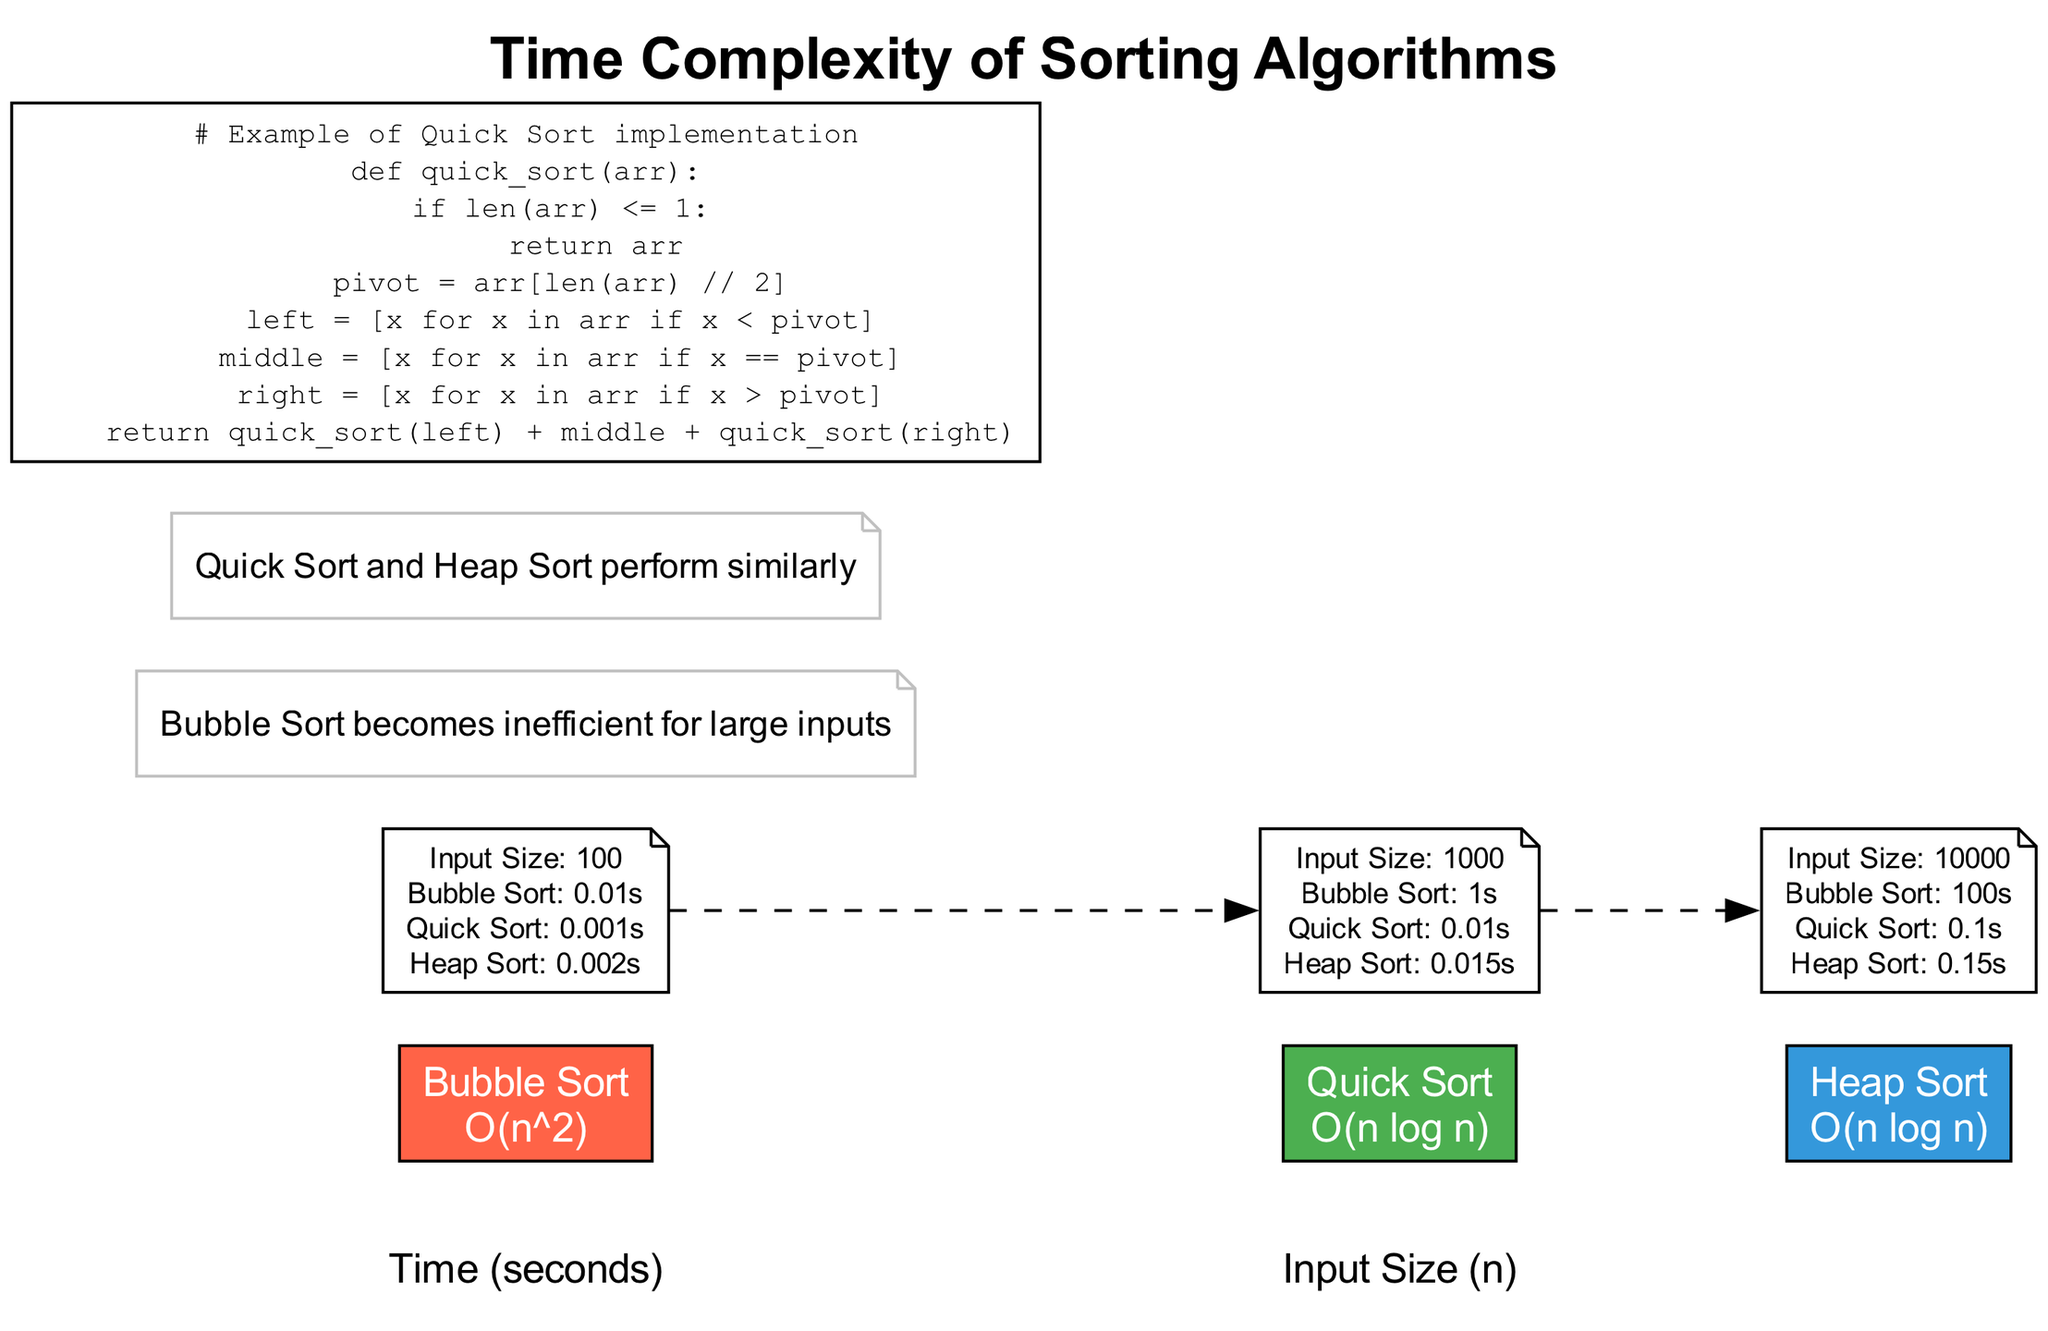What is the time complexity of Quick Sort? The diagram lists the complexity of Quick Sort under its name as "O(n log n)". This is standard information indicated directly within the visual representation of the algorithm.
Answer: O(n log n) What appears to be less efficient for large inputs? The annotation in the diagram explicitly points out that "Bubble Sort becomes inefficient for large inputs", indicating its performance issues as the input size increases.
Answer: Bubble Sort How long does Heap Sort take for an input size of 10,000? For an input size of 10,000, the diagram shows that Heap Sort takes 0.15 seconds. This value is directly taken from the data points marked for Heap Sort at that specific input size.
Answer: 0.15 seconds Which two sorting algorithms perform similarly? The annotation states that "Quick Sort and Heap Sort perform similarly". This statement compares the two algorithms' performance based on the diagram and draws a conclusion from the data presented visually.
Answer: Quick Sort and Heap Sort What is the input size associated with the Bubble Sort time of 1 second? The diagram indicates that at an input size of 1,000, Bubble Sort takes 1 second. By examining the data points for Bubble Sort, one can see the corresponding input size where this time is recorded.
Answer: 1,000 How many total algorithms are represented in the diagram? The diagram lists a total of three algorithms: Bubble Sort, Quick Sort, and Heap Sort. This count is derived from the individual entries under the algorithms section in the visual representation.
Answer: Three What color represents Quick Sort in the diagram? The diagram assigns the color green (#4CAF50) to Quick Sort. This information is directly provided in the algorithm section of the diagram where color coding is used.
Answer: Green Which sorting algorithm shows the steepest increase in time with larger input sizes? The data for Bubble Sort shows a drastic increase in time from 0.01 seconds at size 100 to 100 seconds at size 10,000, indicating its declining efficiency and exponential growth in time complexity.
Answer: Bubble Sort 